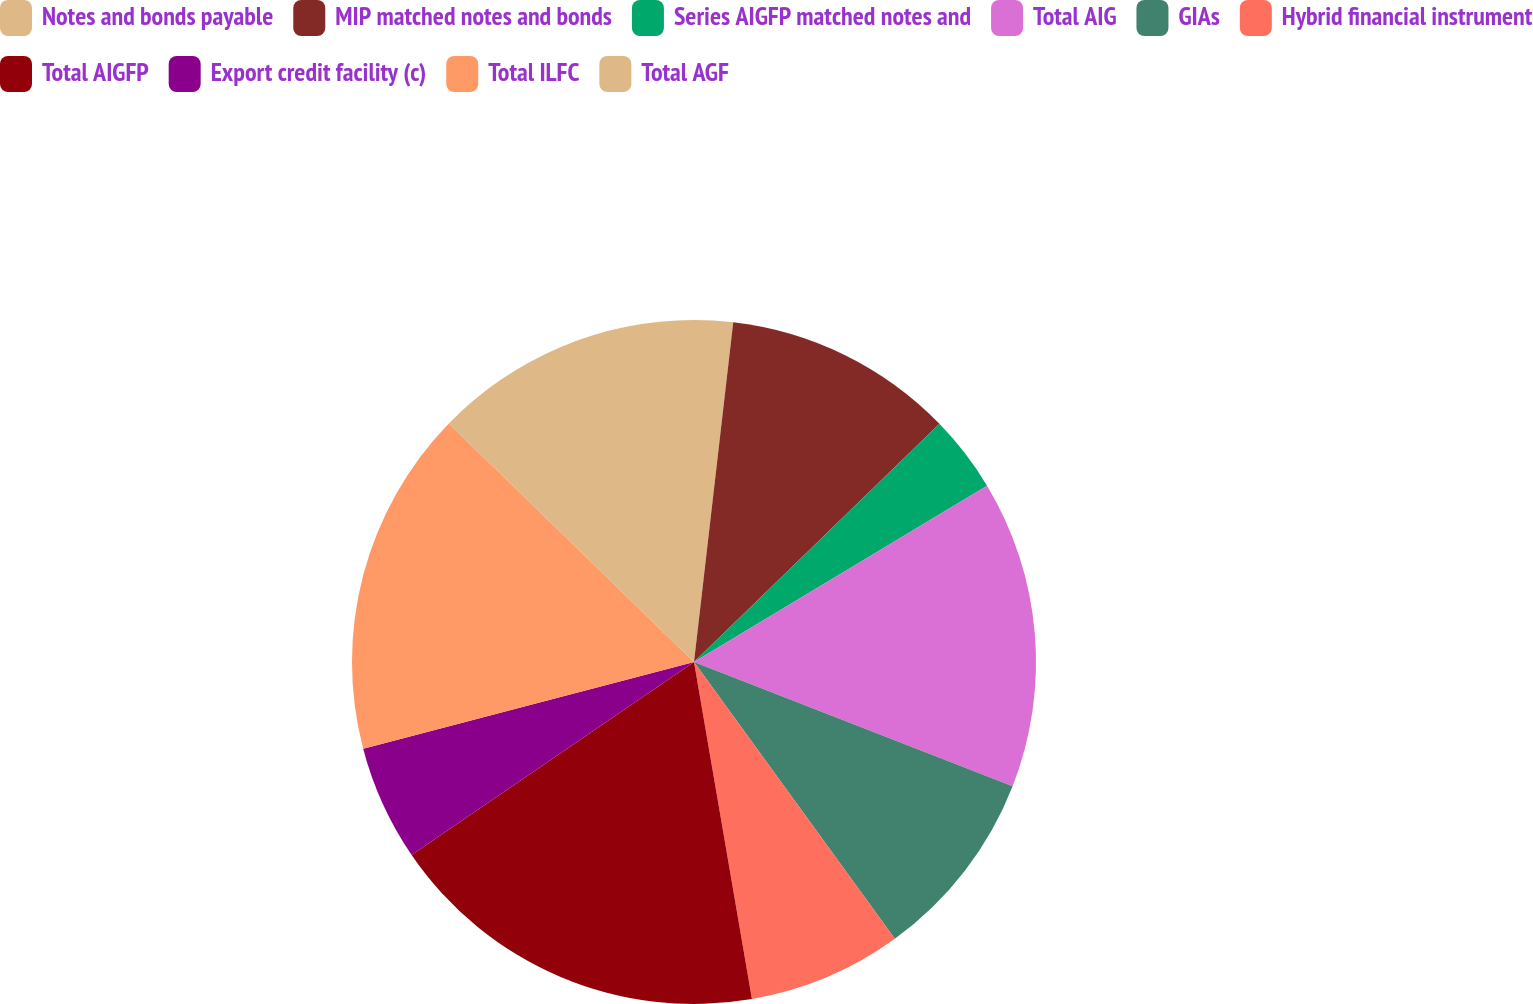Convert chart to OTSL. <chart><loc_0><loc_0><loc_500><loc_500><pie_chart><fcel>Notes and bonds payable<fcel>MIP matched notes and bonds<fcel>Series AIGFP matched notes and<fcel>Total AIG<fcel>GIAs<fcel>Hybrid financial instrument<fcel>Total AIGFP<fcel>Export credit facility (c)<fcel>Total ILFC<fcel>Total AGF<nl><fcel>1.83%<fcel>10.91%<fcel>3.64%<fcel>14.54%<fcel>9.09%<fcel>7.28%<fcel>18.17%<fcel>5.46%<fcel>16.36%<fcel>12.72%<nl></chart> 